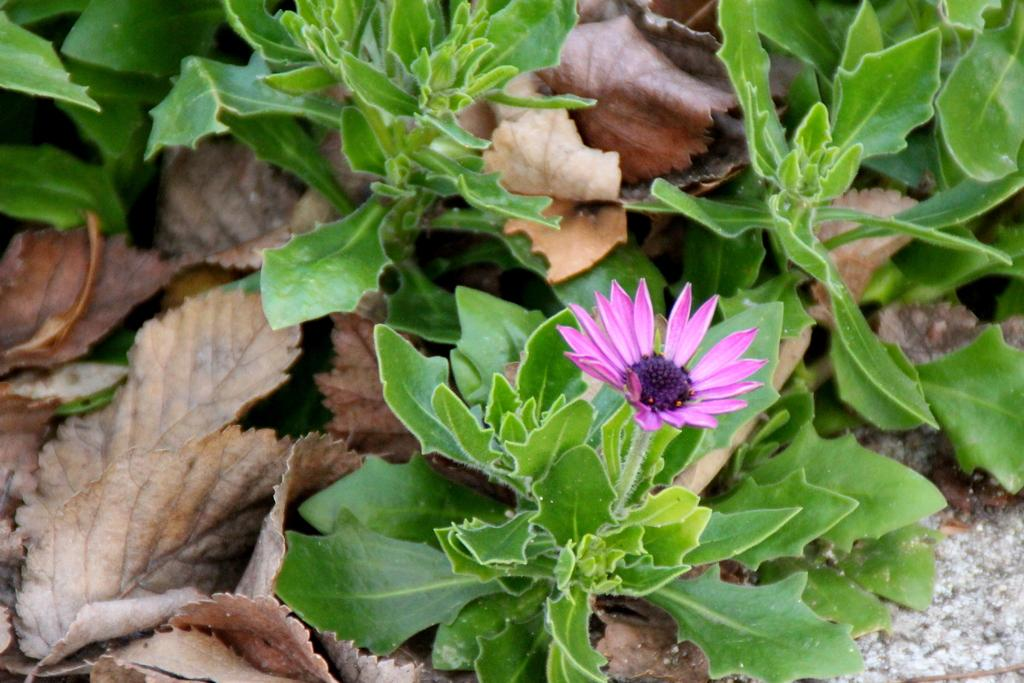What type of flower is in the image? There is a pink and purple flower in the image. Where is the flower located? The flower is on a plant. What else can be seen in the image related to the plant? There are dried leaves visible in the image. What type of magic is being performed by the writer in the image? There is no writer or magic present in the image; it features a flower on a plant with dried leaves. 